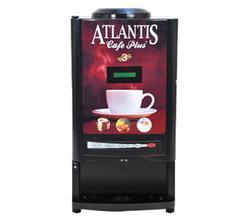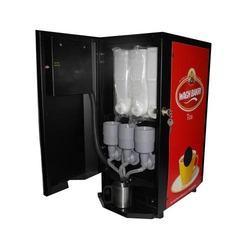The first image is the image on the left, the second image is the image on the right. For the images displayed, is the sentence "In one image the coffee maker is open." factually correct? Answer yes or no. Yes. 